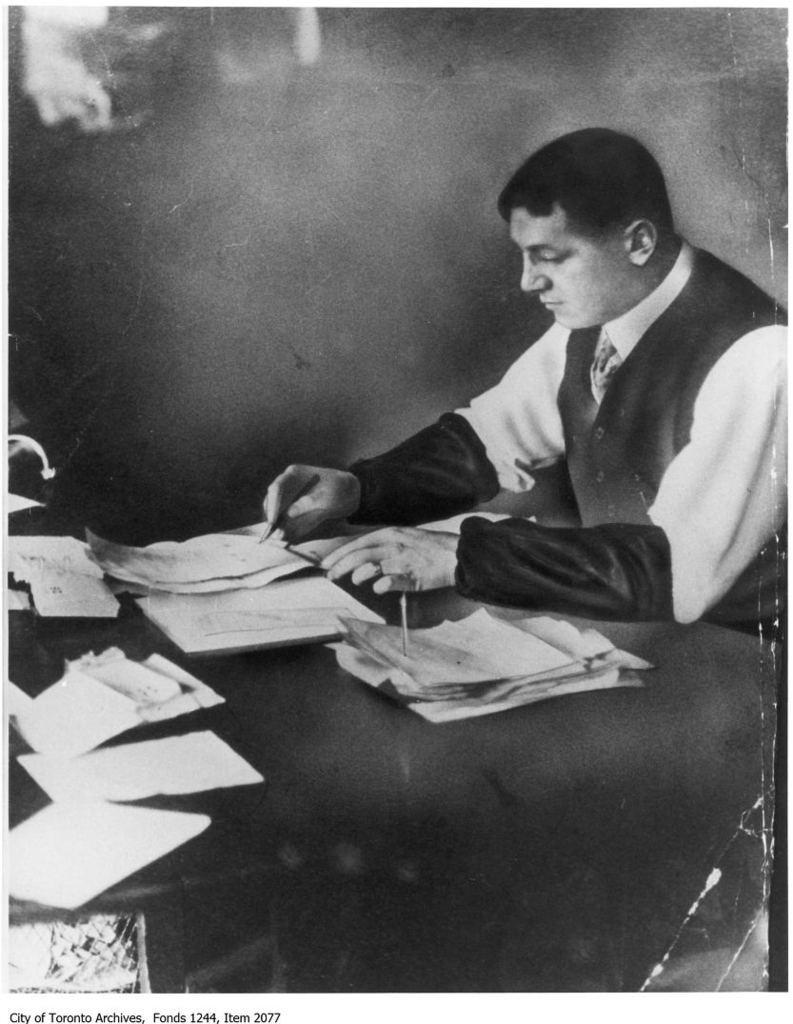Describe this image in one or two sentences. This is a black and white picture. Here we can see a man writing on the paper. This is a table. On the table there are papers. There is a dark background. 